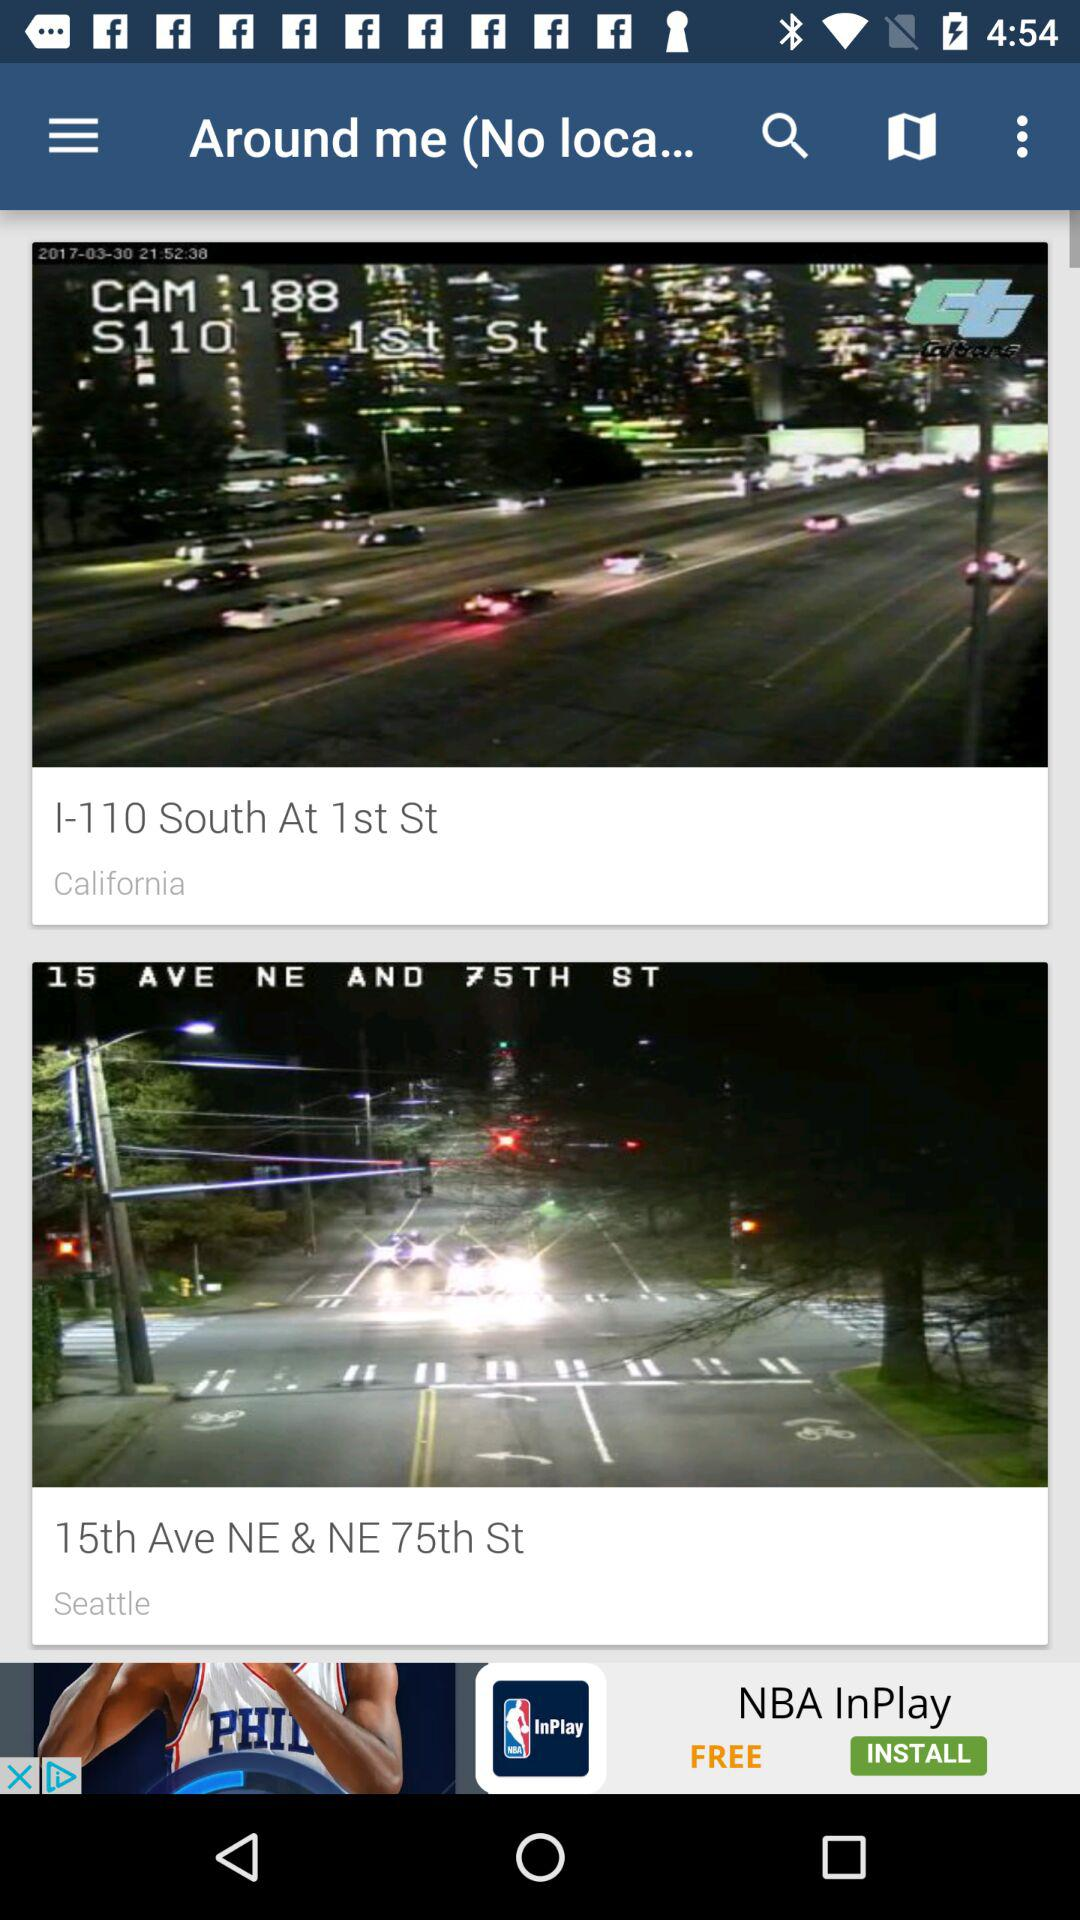What is the location in California? The location is I-110 South at 1st St. 